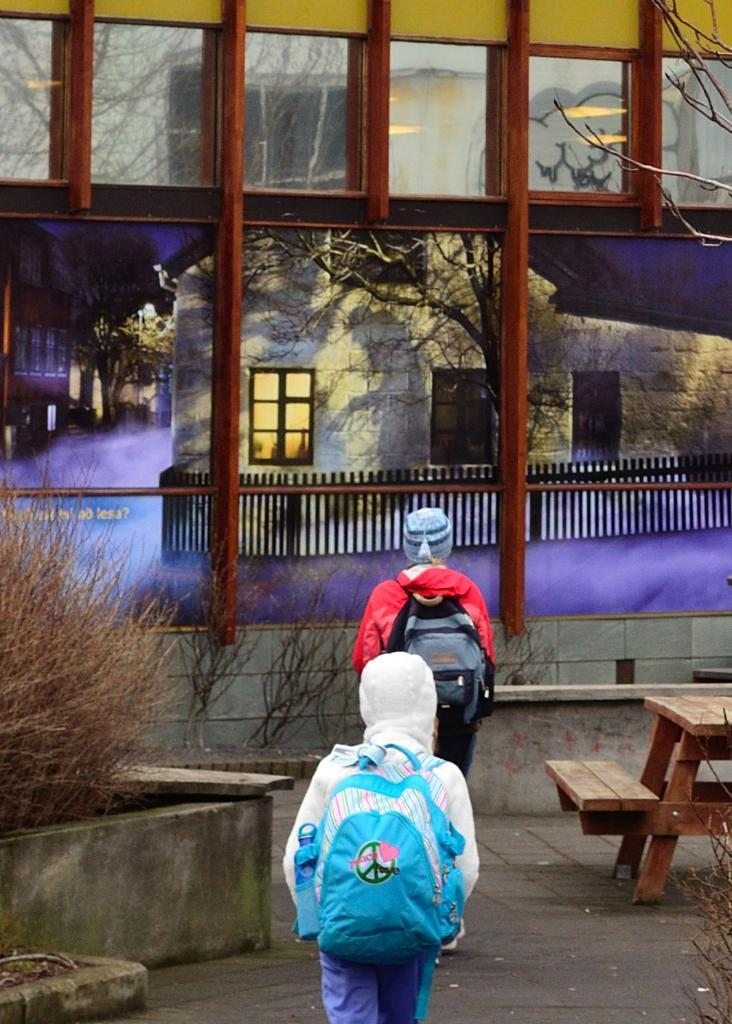How many persons are in the image? There are two persons in the image. What are the persons doing in the image? The persons are walking in the image. What are the persons carrying while walking? The persons are carrying bags. What are the persons wearing on their heads? The persons are wearing caps. What type of seating is present in the image? There is a bench in the image. What type of vegetation is present in the image? There is a plant in the image. What type of structure is present in the image? There is a house in the image. What type of barrier is present in the image? There is a fence in the image. What can be seen through the glass window in the image? Trees are visible through the glass window. What type of metal is used to construct the road in the image? There is no road present in the image; it only features a fence, house, bench, plant, and glass window. 